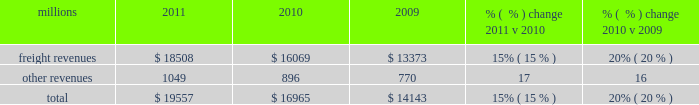F0b7 positive train control 2013 in response to a legislative mandate to implement ptc by the end of 2015 , we expect to spend approximately $ 335 million during 2012 on developing and deploying ptc .
We currently estimate that ptc in accordance with implementing rules issued by the federal rail administration ( fra ) will cost us approximately $ 2 billion by the end of 2015 .
This includes costs for installing the new system along our tracks , upgrading locomotives to work with the new system , and adding digital data communication equipment so all the parts of the system can communicate with each other .
During 2012 , we plan to continue testing the technology to evaluate its effectiveness .
F0b7 financial expectations 2013 we are cautious about the economic environment but anticipate slow but steady volume growth that will exceed 2011 levels .
Coupled with price , on-going network improvements and operational productivity initiatives , we expect earnings that exceed 2011 earnings .
Results of operations operating revenues millions 2011 2010 2009 % (  % ) change 2011 v 2010 % (  % ) change 2010 v 2009 .
We generate freight revenues by transporting freight or other materials from our six commodity groups .
Freight revenues vary with volume ( carloads ) and average revenue per car ( arc ) .
Changes in price , traffic mix and fuel surcharges drive arc .
We provide some of our customers with contractual incentives for meeting or exceeding specified cumulative volumes or shipping to and from specific locations , which we record as reductions to freight revenues based on the actual or projected future shipments .
We recognize freight revenues as shipments move from origin to destination .
We allocate freight revenues between reporting periods based on the relative transit time in each reporting period and recognize expenses as we incur them .
Other revenues include revenues earned by our subsidiaries , revenues from our commuter rail operations , and accessorial revenues , which we earn when customers retain equipment owned or controlled by us or when we perform additional services such as switching or storage .
We recognize other revenues as we perform services or meet contractual obligations .
Freight revenues for all six commodity groups increased during 2011 compared to 2010 , while volume increased in all except intermodal .
Increased demand in many market sectors , with particularly strong growth in chemical , industrial products , and automotive shipments for the year , generated the increases .
Arc increased 12% ( 12 % ) , driven by higher fuel cost recoveries and core pricing gains .
Fuel cost recoveries include fuel surcharge revenue and the impact of resetting the base fuel price for certain traffic , which is described below in more detail .
Higher fuel prices , volume growth , and new fuel surcharge provisions in renegotiated contracts all combined to increase revenues from fuel surcharges .
Freight revenues and volume levels for all six commodity groups increased during 2010 as a result of economic improvement in many market sectors .
We experienced particularly strong volume growth in automotive , intermodal , and industrial products shipments .
Core pricing gains and higher fuel surcharges also increased freight revenues and drove a 6% ( 6 % ) improvement in arc .
Our fuel surcharge programs ( excluding index-based contract escalators that contain some provision for fuel ) generated freight revenues of $ 2.2 billion , $ 1.2 billion , and $ 605 million in 2011 , 2010 , and 2009 , respectively .
Higher fuel prices , volume growth , and new fuel surcharge provisions in contracts renegotiated during the year increased fuel surcharge amounts in 2011 and 2010 .
Furthermore , for certain periods during 2009 , fuel prices dropped below the base at which our mileage-based fuel surcharge begins , which resulted in no fuel surcharge recovery for associated shipments during those periods .
Additionally , fuel surcharge revenue is not entirely comparable to prior periods as we continue to convert portions of our non-regulated traffic to mileage-based fuel surcharge programs .
In 2011 , other revenues increased from 2010 due primarily to higher revenues at our subsidiaries that broker intermodal and automotive services. .
What percentage of total revenue in 2011 was freight revenue? 
Computations: (18508 / 19557)
Answer: 0.94636. 